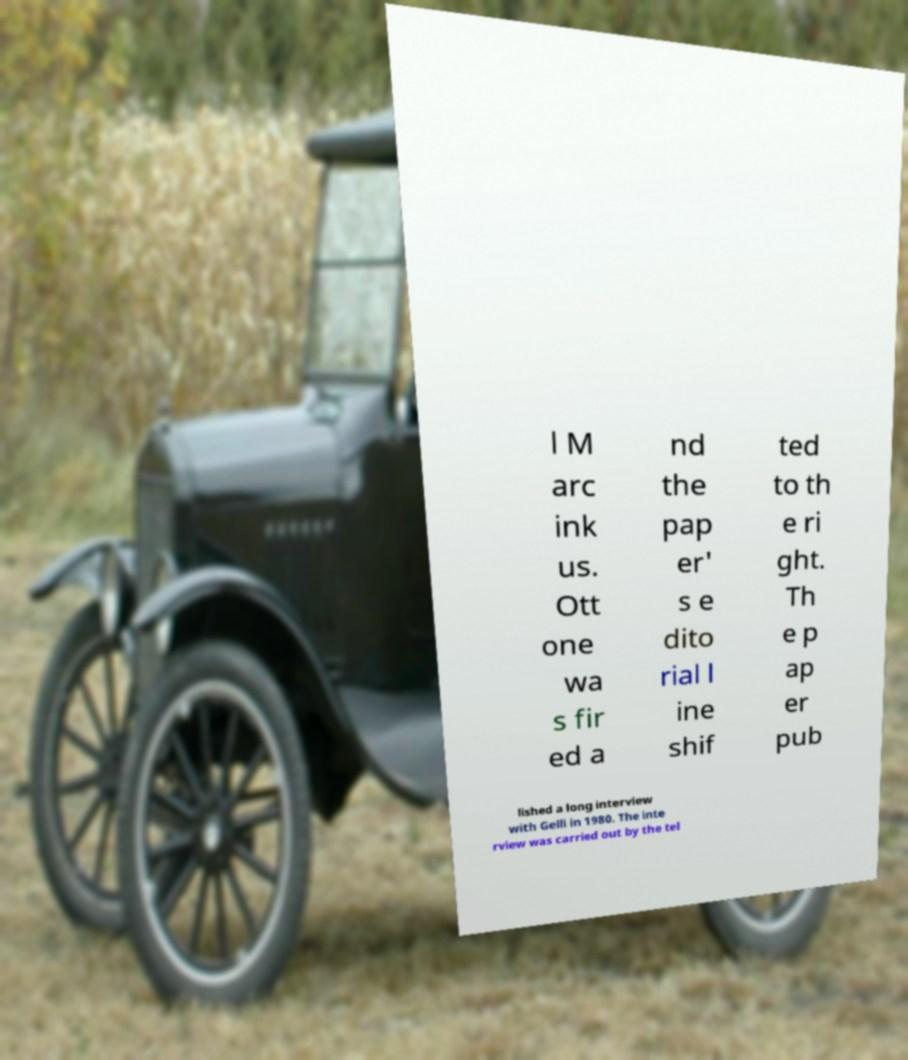There's text embedded in this image that I need extracted. Can you transcribe it verbatim? l M arc ink us. Ott one wa s fir ed a nd the pap er' s e dito rial l ine shif ted to th e ri ght. Th e p ap er pub lished a long interview with Gelli in 1980. The inte rview was carried out by the tel 